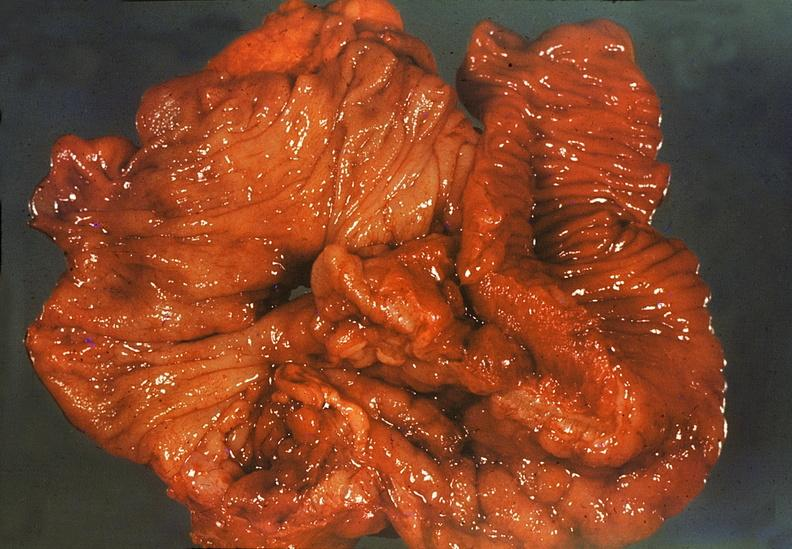s cachexia present?
Answer the question using a single word or phrase. No 